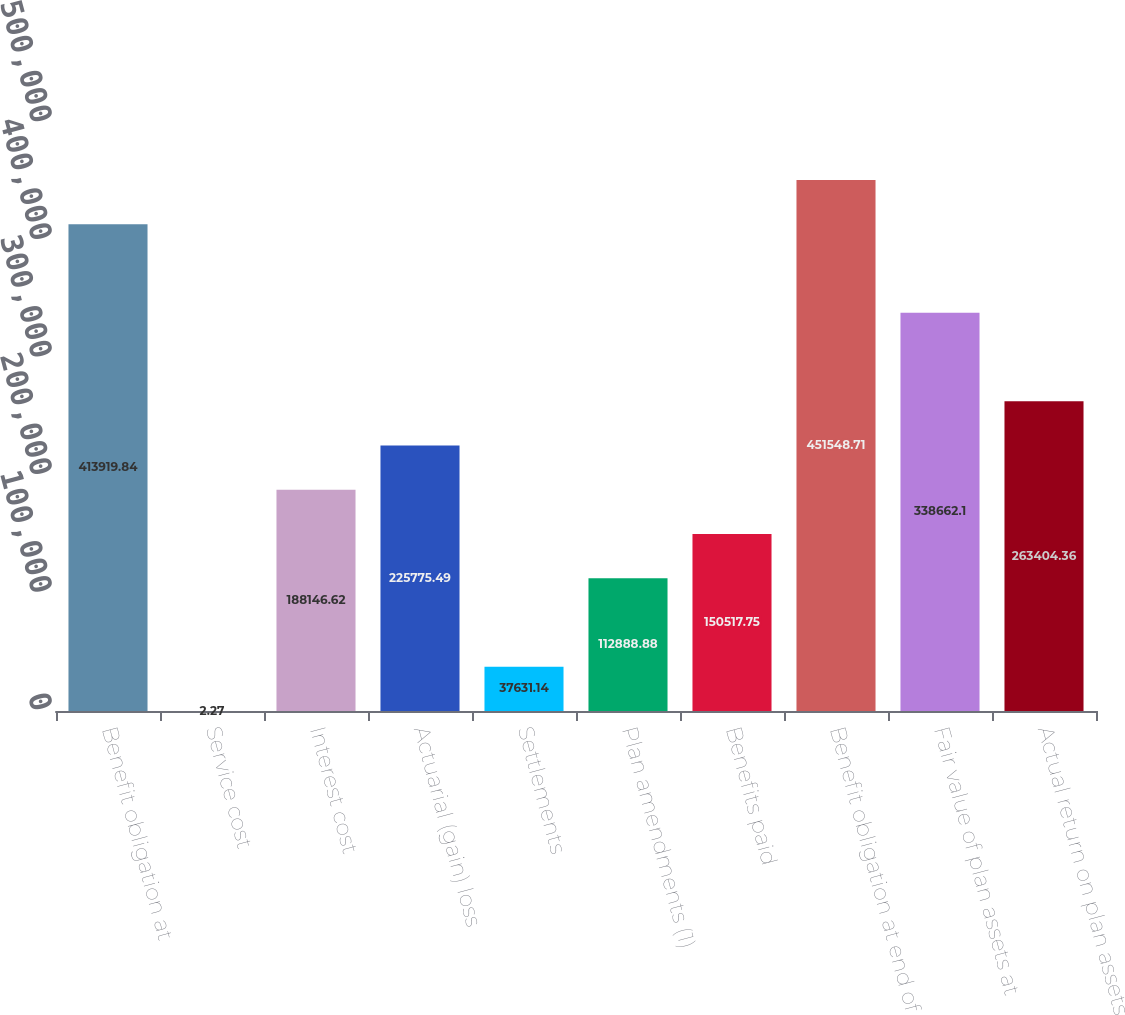Convert chart. <chart><loc_0><loc_0><loc_500><loc_500><bar_chart><fcel>Benefit obligation at<fcel>Service cost<fcel>Interest cost<fcel>Actuarial (gain) loss<fcel>Settlements<fcel>Plan amendments (1)<fcel>Benefits paid<fcel>Benefit obligation at end of<fcel>Fair value of plan assets at<fcel>Actual return on plan assets<nl><fcel>413920<fcel>2.27<fcel>188147<fcel>225775<fcel>37631.1<fcel>112889<fcel>150518<fcel>451549<fcel>338662<fcel>263404<nl></chart> 